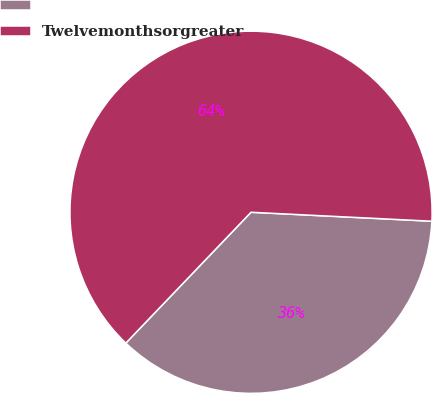Convert chart to OTSL. <chart><loc_0><loc_0><loc_500><loc_500><pie_chart><ecel><fcel>Twelvemonthsorgreater<nl><fcel>36.36%<fcel>63.64%<nl></chart> 